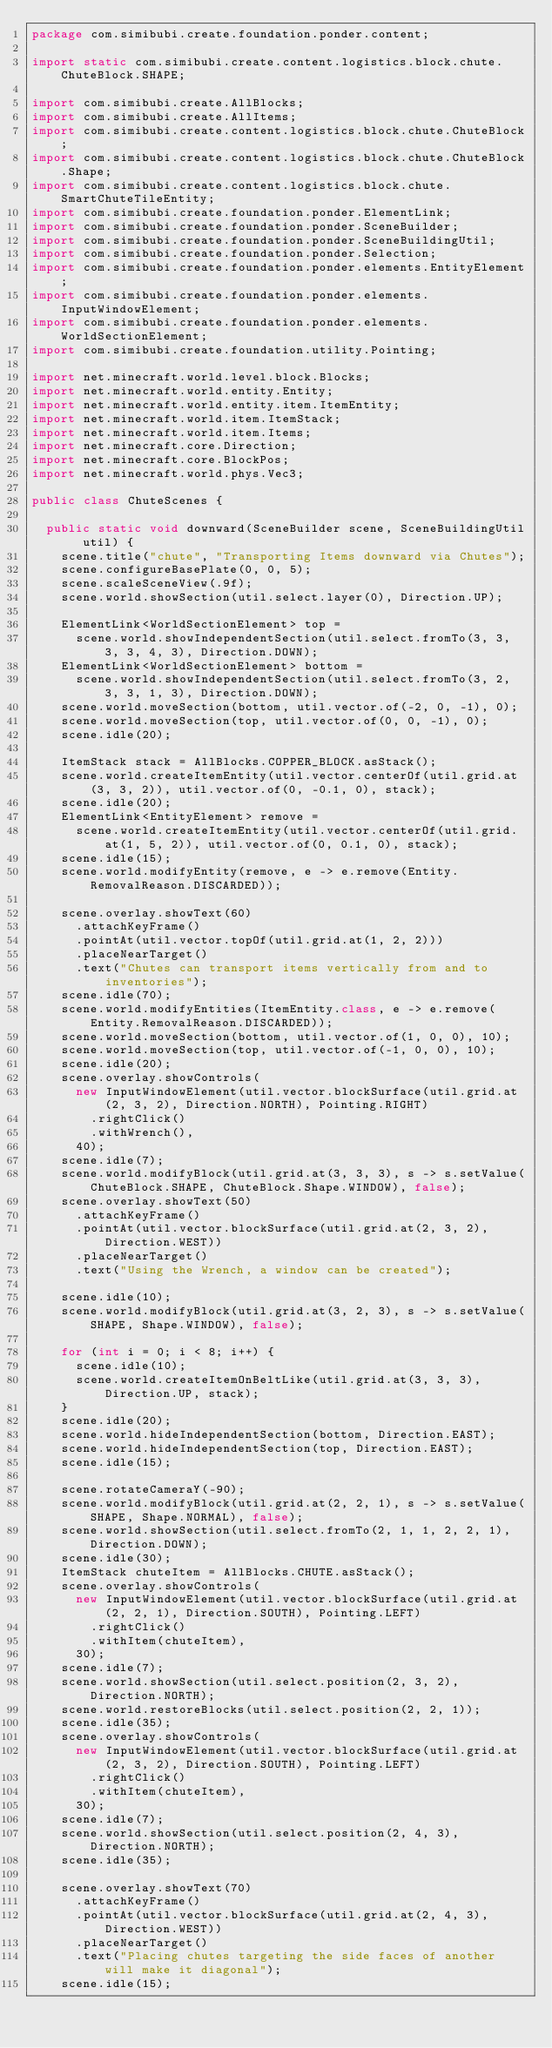Convert code to text. <code><loc_0><loc_0><loc_500><loc_500><_Java_>package com.simibubi.create.foundation.ponder.content;

import static com.simibubi.create.content.logistics.block.chute.ChuteBlock.SHAPE;

import com.simibubi.create.AllBlocks;
import com.simibubi.create.AllItems;
import com.simibubi.create.content.logistics.block.chute.ChuteBlock;
import com.simibubi.create.content.logistics.block.chute.ChuteBlock.Shape;
import com.simibubi.create.content.logistics.block.chute.SmartChuteTileEntity;
import com.simibubi.create.foundation.ponder.ElementLink;
import com.simibubi.create.foundation.ponder.SceneBuilder;
import com.simibubi.create.foundation.ponder.SceneBuildingUtil;
import com.simibubi.create.foundation.ponder.Selection;
import com.simibubi.create.foundation.ponder.elements.EntityElement;
import com.simibubi.create.foundation.ponder.elements.InputWindowElement;
import com.simibubi.create.foundation.ponder.elements.WorldSectionElement;
import com.simibubi.create.foundation.utility.Pointing;

import net.minecraft.world.level.block.Blocks;
import net.minecraft.world.entity.Entity;
import net.minecraft.world.entity.item.ItemEntity;
import net.minecraft.world.item.ItemStack;
import net.minecraft.world.item.Items;
import net.minecraft.core.Direction;
import net.minecraft.core.BlockPos;
import net.minecraft.world.phys.Vec3;

public class ChuteScenes {

	public static void downward(SceneBuilder scene, SceneBuildingUtil util) {
		scene.title("chute", "Transporting Items downward via Chutes");
		scene.configureBasePlate(0, 0, 5);
		scene.scaleSceneView(.9f);
		scene.world.showSection(util.select.layer(0), Direction.UP);

		ElementLink<WorldSectionElement> top =
			scene.world.showIndependentSection(util.select.fromTo(3, 3, 3, 3, 4, 3), Direction.DOWN);
		ElementLink<WorldSectionElement> bottom =
			scene.world.showIndependentSection(util.select.fromTo(3, 2, 3, 3, 1, 3), Direction.DOWN);
		scene.world.moveSection(bottom, util.vector.of(-2, 0, -1), 0);
		scene.world.moveSection(top, util.vector.of(0, 0, -1), 0);
		scene.idle(20);

		ItemStack stack = AllBlocks.COPPER_BLOCK.asStack();
		scene.world.createItemEntity(util.vector.centerOf(util.grid.at(3, 3, 2)), util.vector.of(0, -0.1, 0), stack);
		scene.idle(20);
		ElementLink<EntityElement> remove =
			scene.world.createItemEntity(util.vector.centerOf(util.grid.at(1, 5, 2)), util.vector.of(0, 0.1, 0), stack);
		scene.idle(15);
		scene.world.modifyEntity(remove, e -> e.remove(Entity.RemovalReason.DISCARDED));

		scene.overlay.showText(60)
			.attachKeyFrame()
			.pointAt(util.vector.topOf(util.grid.at(1, 2, 2)))
			.placeNearTarget()
			.text("Chutes can transport items vertically from and to inventories");
		scene.idle(70);
		scene.world.modifyEntities(ItemEntity.class, e -> e.remove(Entity.RemovalReason.DISCARDED));
		scene.world.moveSection(bottom, util.vector.of(1, 0, 0), 10);
		scene.world.moveSection(top, util.vector.of(-1, 0, 0), 10);
		scene.idle(20);
		scene.overlay.showControls(
			new InputWindowElement(util.vector.blockSurface(util.grid.at(2, 3, 2), Direction.NORTH), Pointing.RIGHT)
				.rightClick()
				.withWrench(),
			40);
		scene.idle(7);
		scene.world.modifyBlock(util.grid.at(3, 3, 3), s -> s.setValue(ChuteBlock.SHAPE, ChuteBlock.Shape.WINDOW), false);
		scene.overlay.showText(50)
			.attachKeyFrame()
			.pointAt(util.vector.blockSurface(util.grid.at(2, 3, 2), Direction.WEST))
			.placeNearTarget()
			.text("Using the Wrench, a window can be created");

		scene.idle(10);
		scene.world.modifyBlock(util.grid.at(3, 2, 3), s -> s.setValue(SHAPE, Shape.WINDOW), false);

		for (int i = 0; i < 8; i++) {
			scene.idle(10);
			scene.world.createItemOnBeltLike(util.grid.at(3, 3, 3), Direction.UP, stack);
		}
		scene.idle(20);
		scene.world.hideIndependentSection(bottom, Direction.EAST);
		scene.world.hideIndependentSection(top, Direction.EAST);
		scene.idle(15);

		scene.rotateCameraY(-90);
		scene.world.modifyBlock(util.grid.at(2, 2, 1), s -> s.setValue(SHAPE, Shape.NORMAL), false);
		scene.world.showSection(util.select.fromTo(2, 1, 1, 2, 2, 1), Direction.DOWN);
		scene.idle(30);
		ItemStack chuteItem = AllBlocks.CHUTE.asStack();
		scene.overlay.showControls(
			new InputWindowElement(util.vector.blockSurface(util.grid.at(2, 2, 1), Direction.SOUTH), Pointing.LEFT)
				.rightClick()
				.withItem(chuteItem),
			30);
		scene.idle(7);
		scene.world.showSection(util.select.position(2, 3, 2), Direction.NORTH);
		scene.world.restoreBlocks(util.select.position(2, 2, 1));
		scene.idle(35);
		scene.overlay.showControls(
			new InputWindowElement(util.vector.blockSurface(util.grid.at(2, 3, 2), Direction.SOUTH), Pointing.LEFT)
				.rightClick()
				.withItem(chuteItem),
			30);
		scene.idle(7);
		scene.world.showSection(util.select.position(2, 4, 3), Direction.NORTH);
		scene.idle(35);

		scene.overlay.showText(70)
			.attachKeyFrame()
			.pointAt(util.vector.blockSurface(util.grid.at(2, 4, 3), Direction.WEST))
			.placeNearTarget()
			.text("Placing chutes targeting the side faces of another will make it diagonal");
		scene.idle(15);</code> 